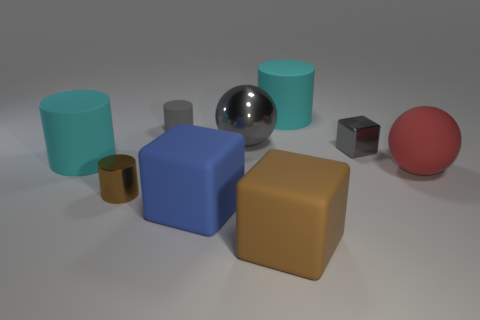Are there any large metal spheres of the same color as the shiny cube?
Offer a very short reply. Yes. There is a matte object that is the same color as the big shiny sphere; what shape is it?
Your answer should be very brief. Cylinder. Is the gray cube made of the same material as the big gray object?
Offer a very short reply. Yes. Are there more big matte cylinders that are behind the shiny cube than small purple matte cylinders?
Your response must be concise. Yes. What material is the large cylinder that is to the right of the big cylinder that is to the left of the cyan rubber object on the right side of the tiny metallic cylinder?
Ensure brevity in your answer.  Rubber. How many things are brown rubber cubes or rubber things behind the big red ball?
Your answer should be compact. 4. There is a ball that is left of the big brown rubber object; is it the same color as the small cube?
Your answer should be very brief. Yes. Is the number of gray cylinders left of the small gray shiny cube greater than the number of big cyan cylinders right of the red sphere?
Provide a succinct answer. Yes. Is there any other thing of the same color as the metallic sphere?
Your answer should be compact. Yes. How many objects are large red balls or shiny spheres?
Your answer should be compact. 2. 